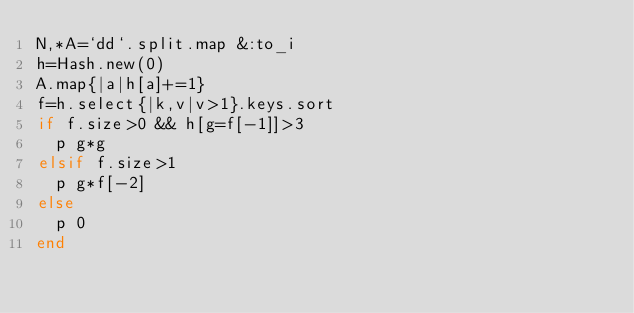<code> <loc_0><loc_0><loc_500><loc_500><_Ruby_>N,*A=`dd`.split.map &:to_i
h=Hash.new(0)
A.map{|a|h[a]+=1}
f=h.select{|k,v|v>1}.keys.sort
if f.size>0 && h[g=f[-1]]>3
  p g*g
elsif f.size>1
  p g*f[-2]
else
  p 0
end</code> 